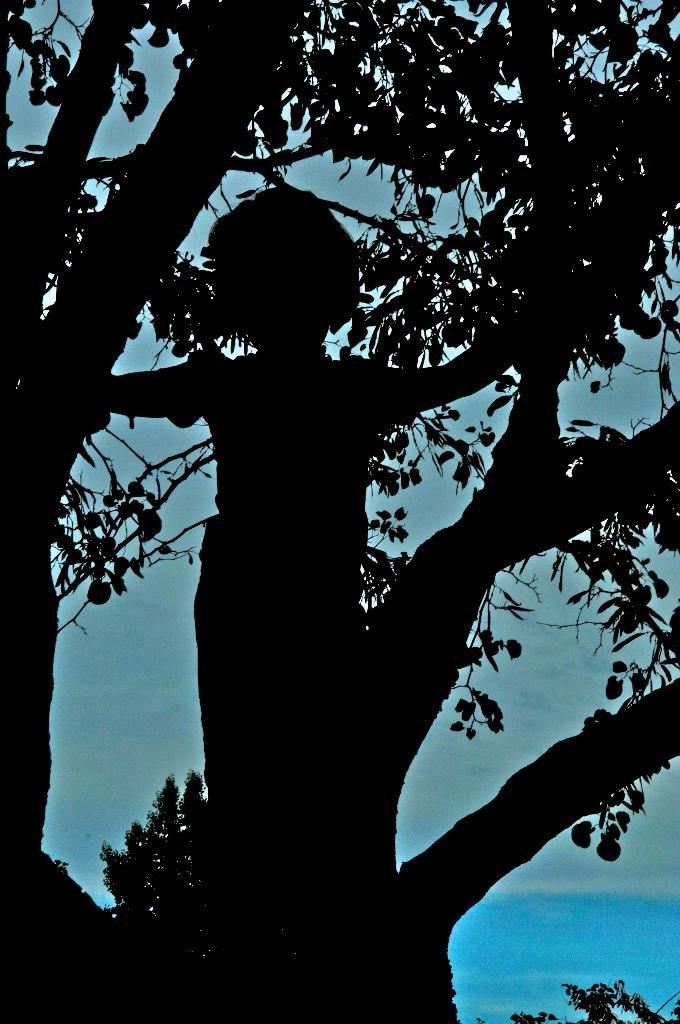What is the main object in the image? There is a tree in the image. Is there anyone near the tree? Yes, there is a person standing next to the tree. What color is the background of the image? The background of the image is blue. Can you see any ladybugs crawling on the tree in the image? There is no mention of ladybugs in the image, so it cannot be determined if any are present. What type of wine is being served at the event in the image? There is no event or wine present in the image; it features a tree and a person standing next to it. 